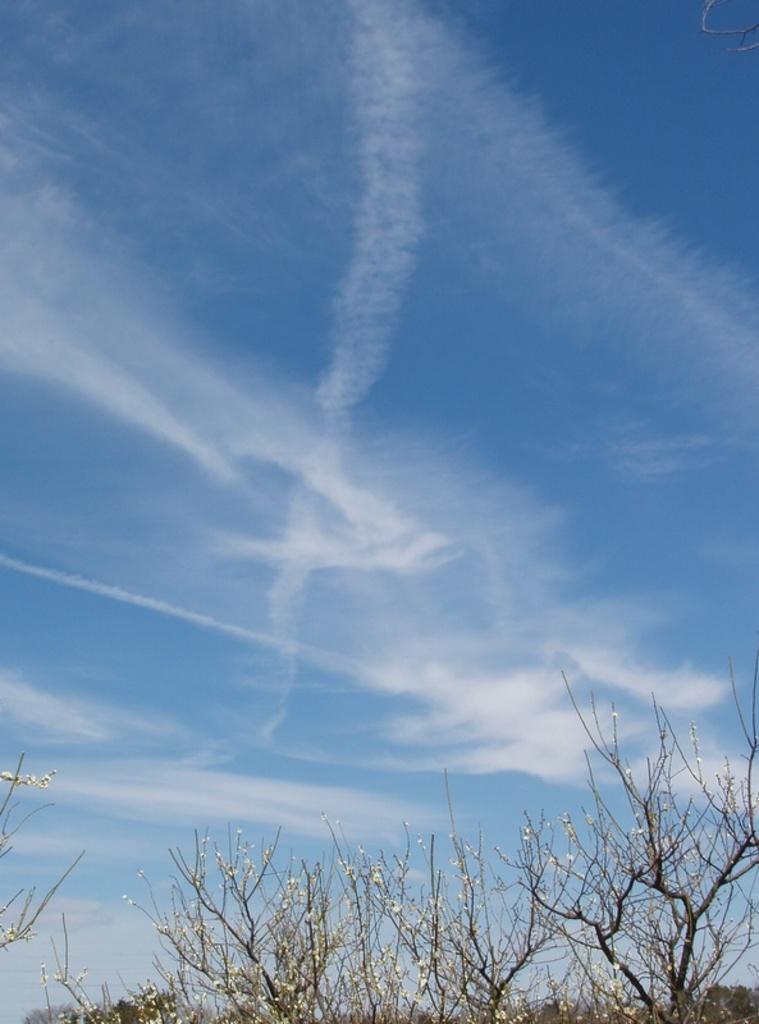Could you give a brief overview of what you see in this image? In this picture I can observe some plants on the ground in the bottom of the picture. In the background there are some clouds in the sky. 